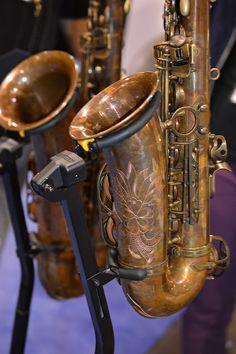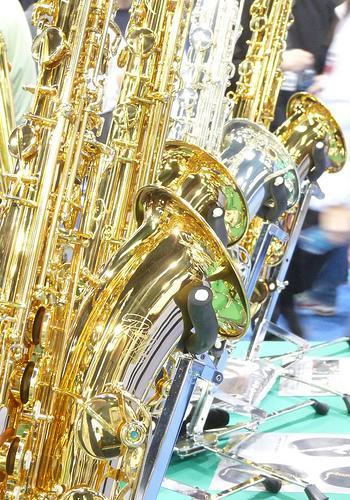The first image is the image on the left, the second image is the image on the right. For the images displayed, is the sentence "No image shows more than one saxophone." factually correct? Answer yes or no. No. The first image is the image on the left, the second image is the image on the right. Analyze the images presented: Is the assertion "There are at exactly two saxophones in one of the images." valid? Answer yes or no. Yes. 